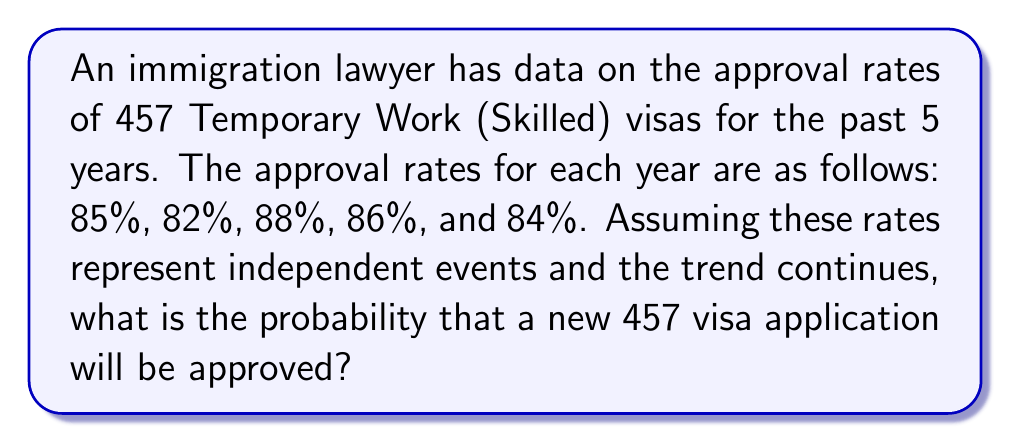Show me your answer to this math problem. To solve this problem, we need to follow these steps:

1) First, we need to calculate the average approval rate over the 5 years.

   Let's add up all the percentages:
   $85\% + 82\% + 88\% + 86\% + 84\% = 425\%$

2) Now, divide by the number of years (5) to get the average:
   $\frac{425\%}{5} = 85\%$

3) Convert this percentage to a decimal:
   $85\% = 0.85$

4) In probability theory, when we assume independent events and a continuing trend, the probability of an event occurring is equal to its average rate of occurrence in the past.

5) Therefore, the probability of a new 457 visa application being approved is 0.85 or 85%.

This approach uses the principle of maximum likelihood estimation in a simplified form, which is a common method in statistics and cryptography for estimating probabilities based on observed data.
Answer: 0.85 